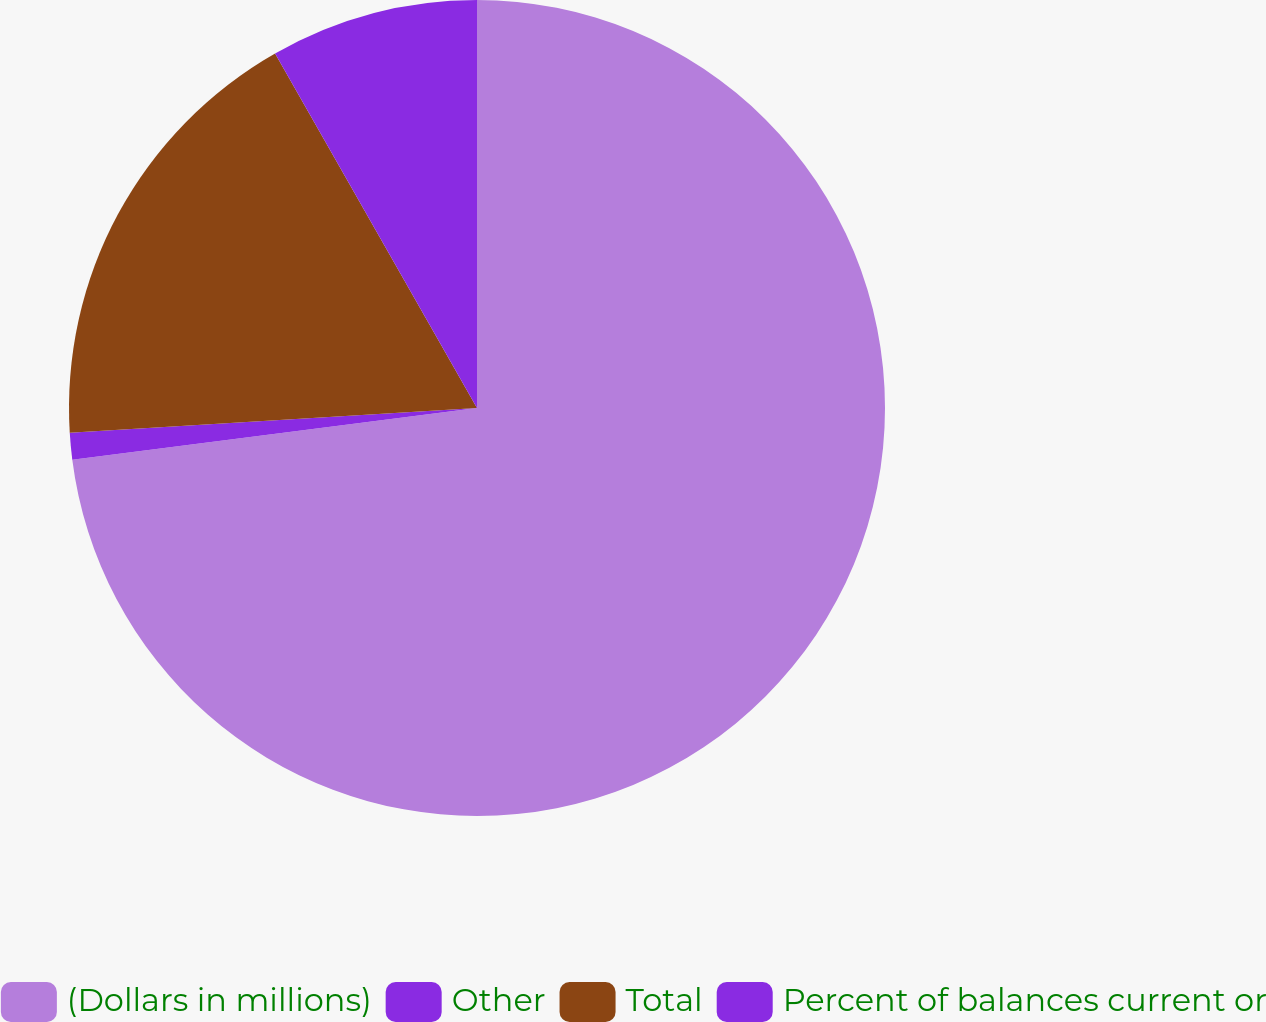Convert chart. <chart><loc_0><loc_0><loc_500><loc_500><pie_chart><fcel>(Dollars in millions)<fcel>Other<fcel>Total<fcel>Percent of balances current or<nl><fcel>72.98%<fcel>1.05%<fcel>17.73%<fcel>8.24%<nl></chart> 